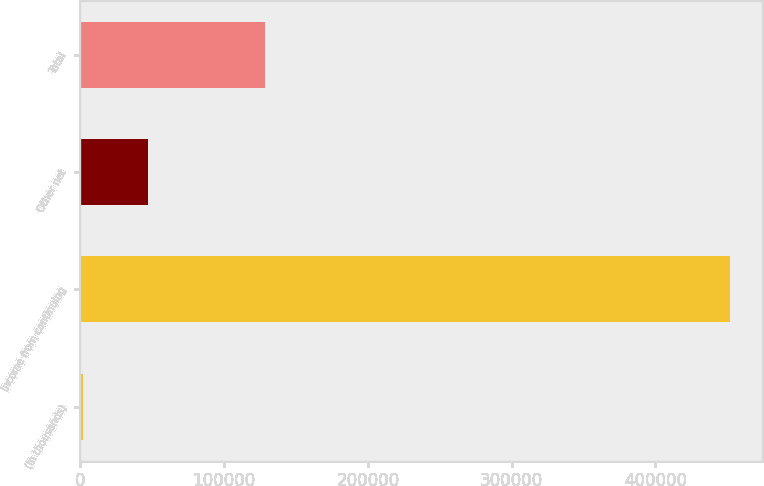<chart> <loc_0><loc_0><loc_500><loc_500><bar_chart><fcel>(In thousands)<fcel>Income from continuing<fcel>Other net<fcel>Total<nl><fcel>2004<fcel>451612<fcel>46964.8<fcel>128290<nl></chart> 